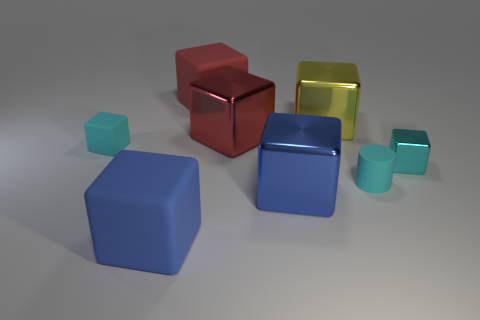Subtract 1 cubes. How many cubes are left? 6 Subtract all blue cubes. How many cubes are left? 5 Subtract all cyan matte cubes. How many cubes are left? 6 Subtract all green cubes. Subtract all green spheres. How many cubes are left? 7 Add 1 cylinders. How many objects exist? 9 Subtract all cylinders. How many objects are left? 7 Add 7 big blue rubber blocks. How many big blue rubber blocks are left? 8 Add 5 yellow metal things. How many yellow metal things exist? 6 Subtract 0 purple cylinders. How many objects are left? 8 Subtract all matte cubes. Subtract all green rubber blocks. How many objects are left? 5 